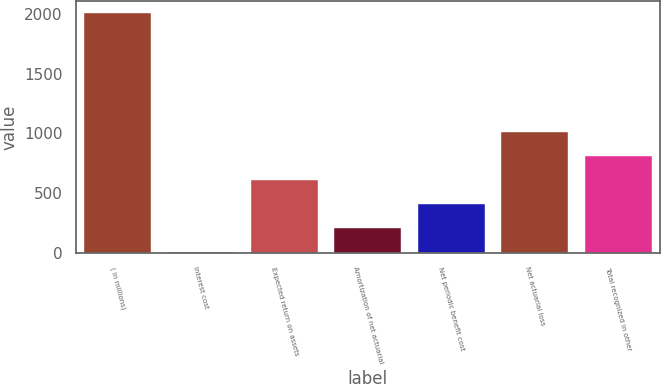Convert chart to OTSL. <chart><loc_0><loc_0><loc_500><loc_500><bar_chart><fcel>( in millions)<fcel>Interest cost<fcel>Expected return on assets<fcel>Amortization of net actuarial<fcel>Net periodic benefit cost<fcel>Net actuarial loss<fcel>Total recognized in other<nl><fcel>2011<fcel>11<fcel>611<fcel>211<fcel>411<fcel>1011<fcel>811<nl></chart> 